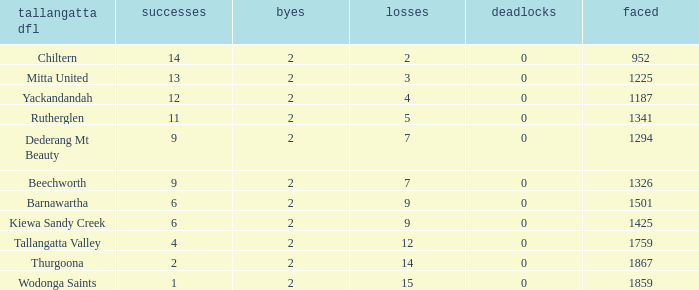What are the fewest draws with less than 7 losses and Mitta United is the Tallagatta DFL? 0.0. Parse the full table. {'header': ['tallangatta dfl', 'successes', 'byes', 'losses', 'deadlocks', 'faced'], 'rows': [['Chiltern', '14', '2', '2', '0', '952'], ['Mitta United', '13', '2', '3', '0', '1225'], ['Yackandandah', '12', '2', '4', '0', '1187'], ['Rutherglen', '11', '2', '5', '0', '1341'], ['Dederang Mt Beauty', '9', '2', '7', '0', '1294'], ['Beechworth', '9', '2', '7', '0', '1326'], ['Barnawartha', '6', '2', '9', '0', '1501'], ['Kiewa Sandy Creek', '6', '2', '9', '0', '1425'], ['Tallangatta Valley', '4', '2', '12', '0', '1759'], ['Thurgoona', '2', '2', '14', '0', '1867'], ['Wodonga Saints', '1', '2', '15', '0', '1859']]} 